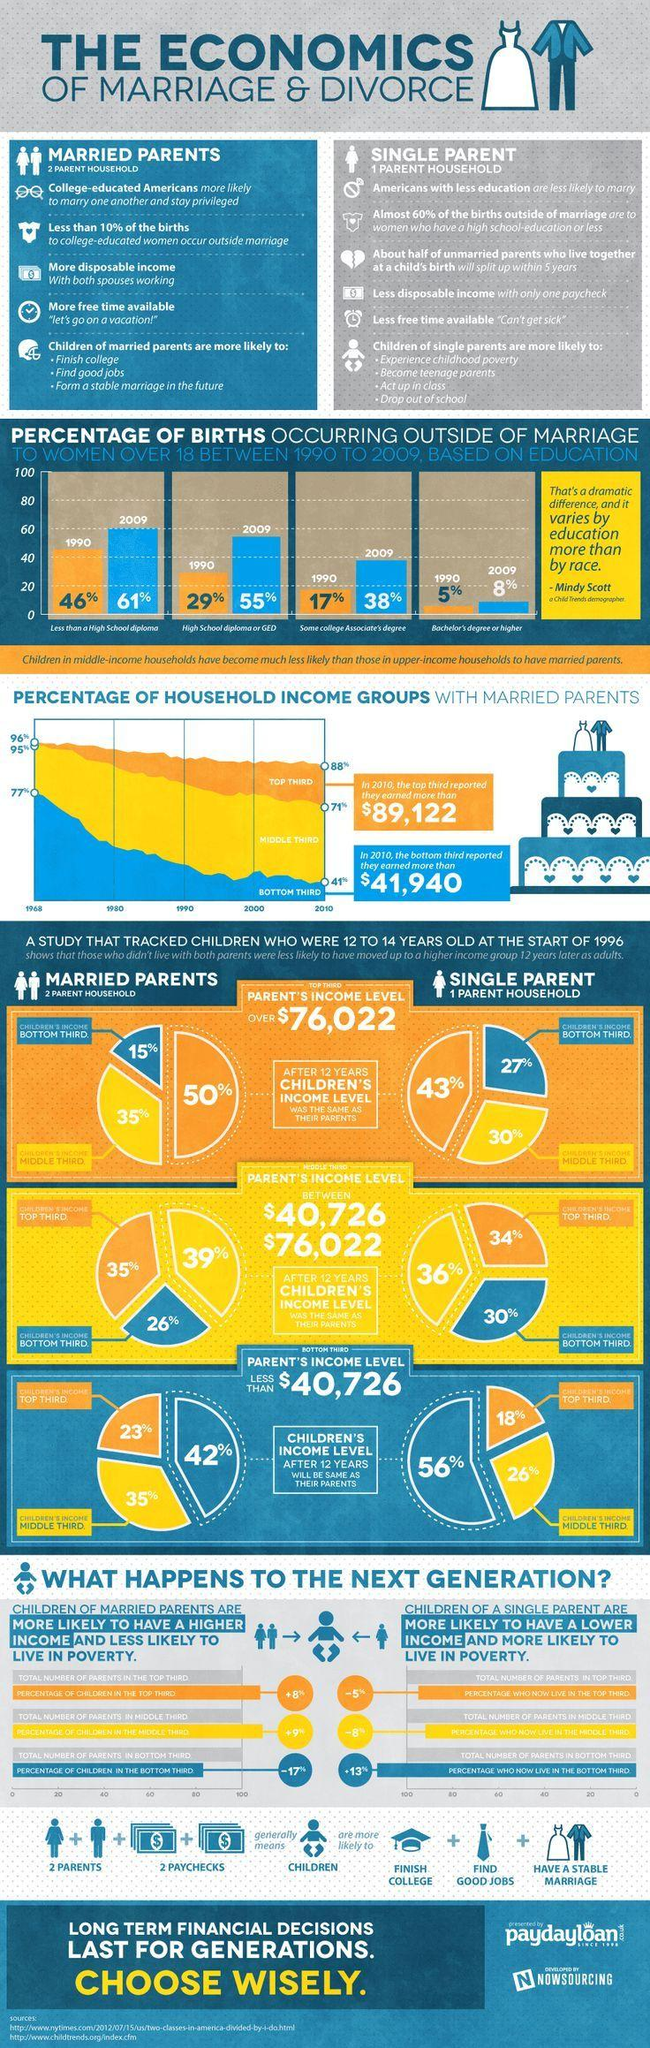Mention a couple of crucial points in this snapshot. In 2009, the percentage of births that occurred outside of marriage when comparing individuals with less than a high school diploma and those with a high school diploma was 116%. There are six points under the heading of single parent. There are five points under the heading 'Married Parents'. In 1990, it was estimated that approximately 75% of births occurred outside of marriage when compared to those with a high school diploma or less. 